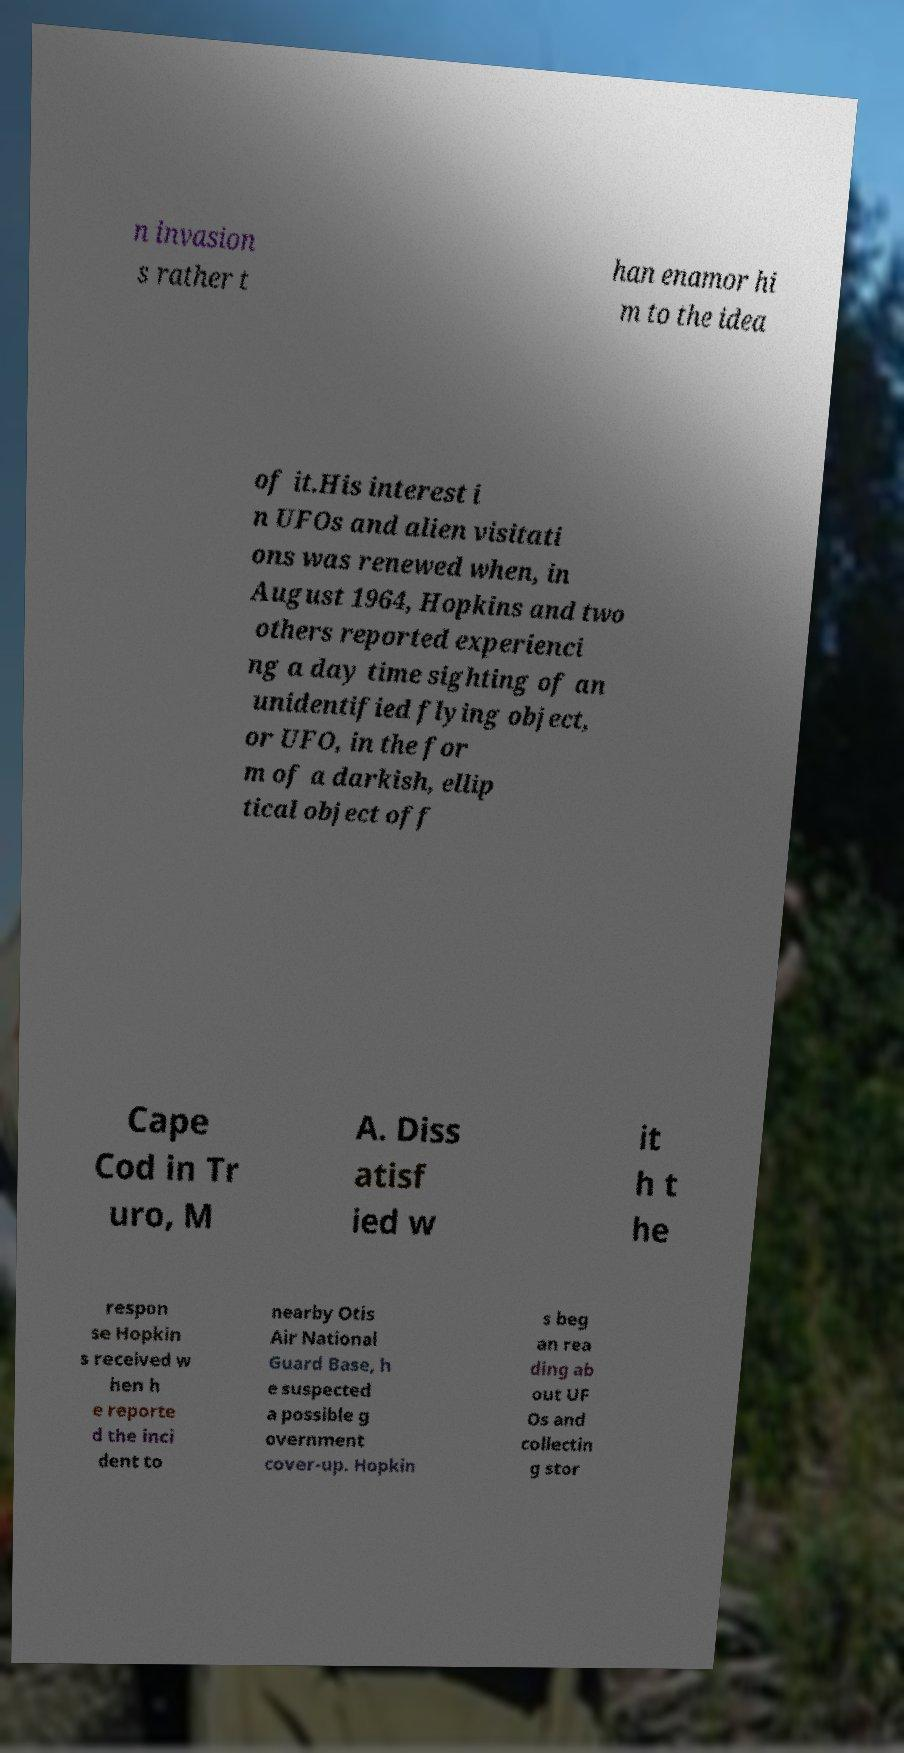Can you accurately transcribe the text from the provided image for me? n invasion s rather t han enamor hi m to the idea of it.His interest i n UFOs and alien visitati ons was renewed when, in August 1964, Hopkins and two others reported experienci ng a day time sighting of an unidentified flying object, or UFO, in the for m of a darkish, ellip tical object off Cape Cod in Tr uro, M A. Diss atisf ied w it h t he respon se Hopkin s received w hen h e reporte d the inci dent to nearby Otis Air National Guard Base, h e suspected a possible g overnment cover-up. Hopkin s beg an rea ding ab out UF Os and collectin g stor 